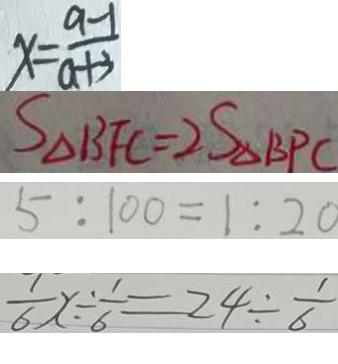<formula> <loc_0><loc_0><loc_500><loc_500>x = \frac { a - 1 } { a + 3 } 
 S _ { \Delta B F C } = 2 S _ { \Delta B P C } 
 5 : 1 0 0 = 1 : 2 0 
 \frac { 1 } { 6 } x \div \frac { 1 } { 6 } = 2 4 \div \frac { 1 } { 6 }</formula> 